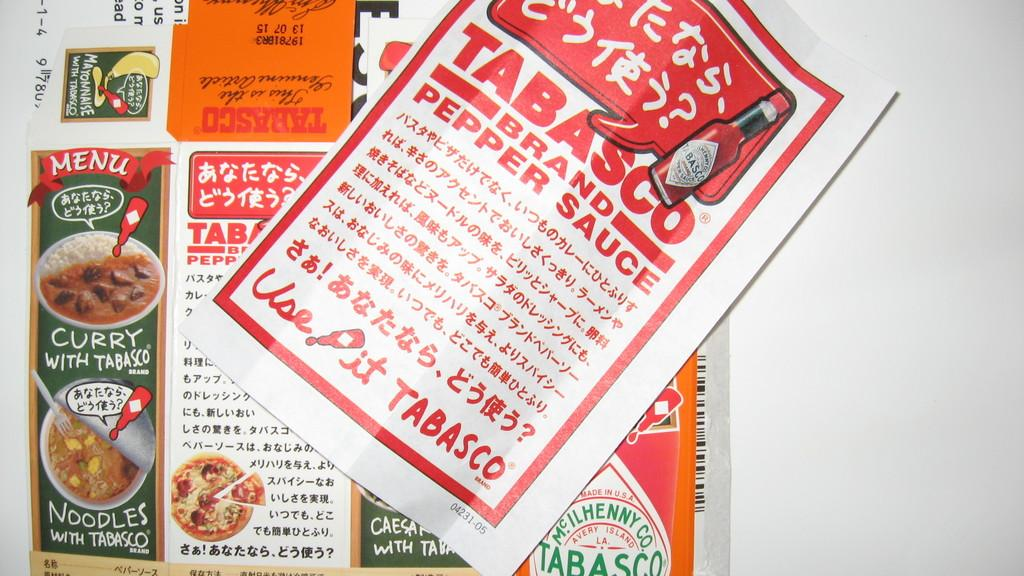What type of product is being advertised in the pamphlet in the image? The pamphlet in the image has an advertisement for pepper sauce. What other items can be seen in the image related to food? There is a paper with advertisements of some curries in the image. How many umbrellas are being advertised in the image? There are no umbrellas being advertised in the image; the image features advertisements for pepper sauce and curries. 